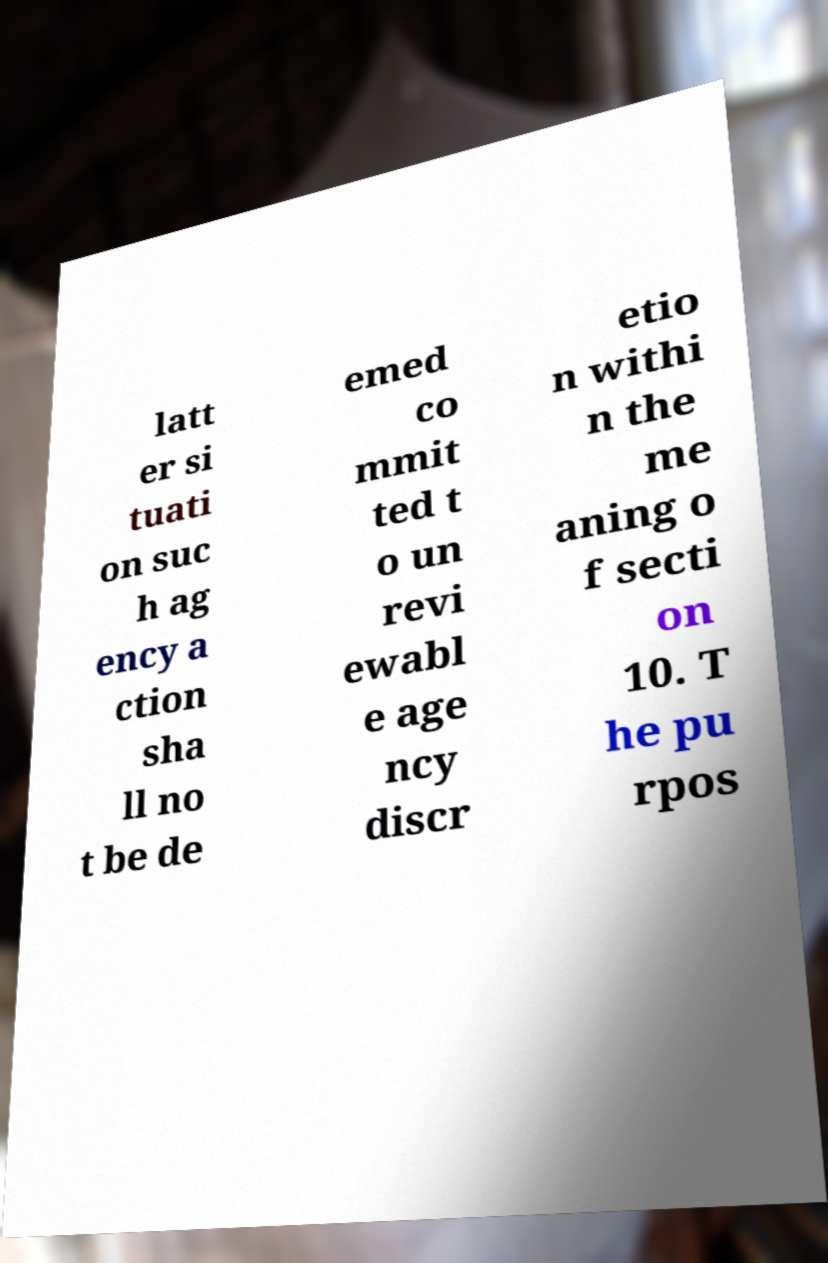Please read and relay the text visible in this image. What does it say? latt er si tuati on suc h ag ency a ction sha ll no t be de emed co mmit ted t o un revi ewabl e age ncy discr etio n withi n the me aning o f secti on 10. T he pu rpos 